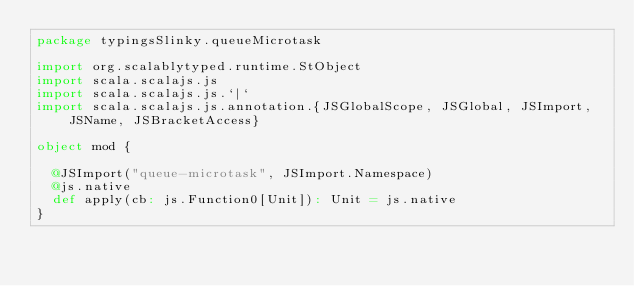<code> <loc_0><loc_0><loc_500><loc_500><_Scala_>package typingsSlinky.queueMicrotask

import org.scalablytyped.runtime.StObject
import scala.scalajs.js
import scala.scalajs.js.`|`
import scala.scalajs.js.annotation.{JSGlobalScope, JSGlobal, JSImport, JSName, JSBracketAccess}

object mod {
  
  @JSImport("queue-microtask", JSImport.Namespace)
  @js.native
  def apply(cb: js.Function0[Unit]): Unit = js.native
}
</code> 